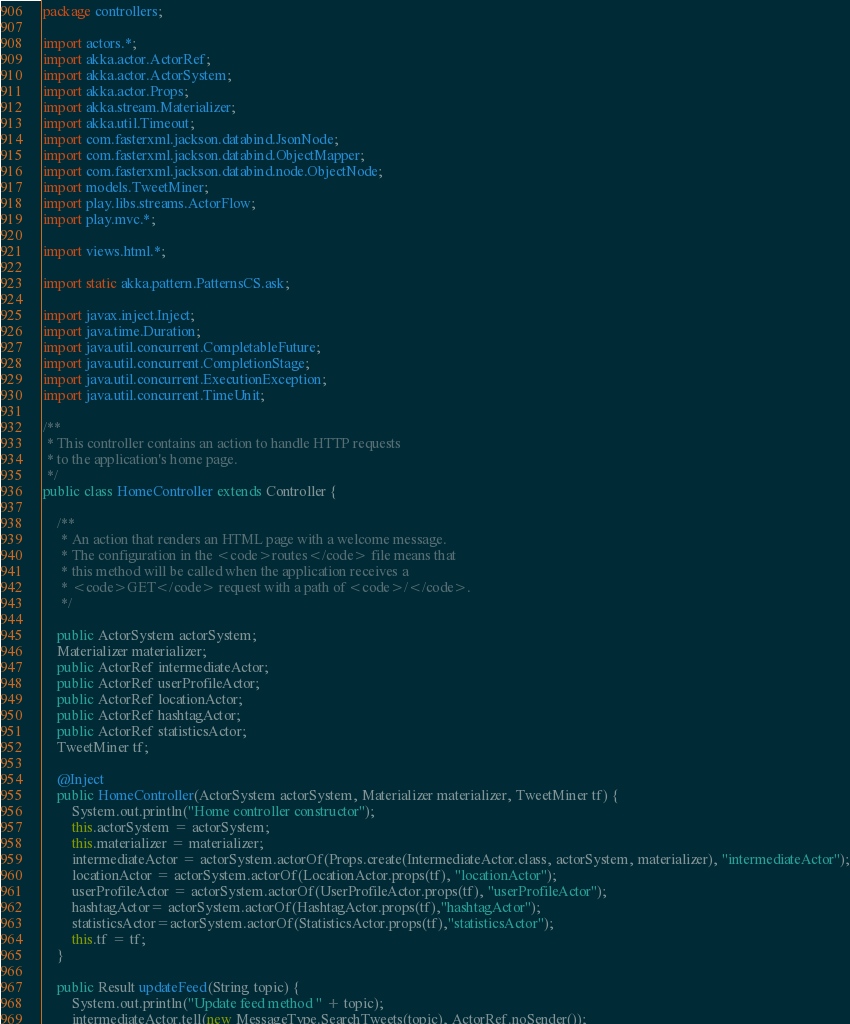Convert code to text. <code><loc_0><loc_0><loc_500><loc_500><_Java_>package controllers;

import actors.*;
import akka.actor.ActorRef;
import akka.actor.ActorSystem;
import akka.actor.Props;
import akka.stream.Materializer;
import akka.util.Timeout;
import com.fasterxml.jackson.databind.JsonNode;
import com.fasterxml.jackson.databind.ObjectMapper;
import com.fasterxml.jackson.databind.node.ObjectNode;
import models.TweetMiner;
import play.libs.streams.ActorFlow;
import play.mvc.*;

import views.html.*;

import static akka.pattern.PatternsCS.ask;

import javax.inject.Inject;
import java.time.Duration;
import java.util.concurrent.CompletableFuture;
import java.util.concurrent.CompletionStage;
import java.util.concurrent.ExecutionException;
import java.util.concurrent.TimeUnit;

/**
 * This controller contains an action to handle HTTP requests
 * to the application's home page.
 */
public class HomeController extends Controller {

    /**
     * An action that renders an HTML page with a welcome message.
     * The configuration in the <code>routes</code> file means that
     * this method will be called when the application receives a
     * <code>GET</code> request with a path of <code>/</code>.
     */

    public ActorSystem actorSystem;
    Materializer materializer;
    public ActorRef intermediateActor;
    public ActorRef userProfileActor;
    public ActorRef locationActor;
    public ActorRef hashtagActor;
    public ActorRef statisticsActor;
    TweetMiner tf;

    @Inject
    public HomeController(ActorSystem actorSystem, Materializer materializer, TweetMiner tf) {
        System.out.println("Home controller constructor");
        this.actorSystem = actorSystem;
        this.materializer = materializer;
        intermediateActor = actorSystem.actorOf(Props.create(IntermediateActor.class, actorSystem, materializer), "intermediateActor");
        locationActor = actorSystem.actorOf(LocationActor.props(tf), "locationActor");
        userProfileActor = actorSystem.actorOf(UserProfileActor.props(tf), "userProfileActor");
        hashtagActor= actorSystem.actorOf(HashtagActor.props(tf),"hashtagActor");
        statisticsActor=actorSystem.actorOf(StatisticsActor.props(tf),"statisticsActor");
        this.tf = tf;
    }

    public Result updateFeed(String topic) {
        System.out.println("Update feed method " + topic);
        intermediateActor.tell(new MessageType.SearchTweets(topic), ActorRef.noSender());</code> 